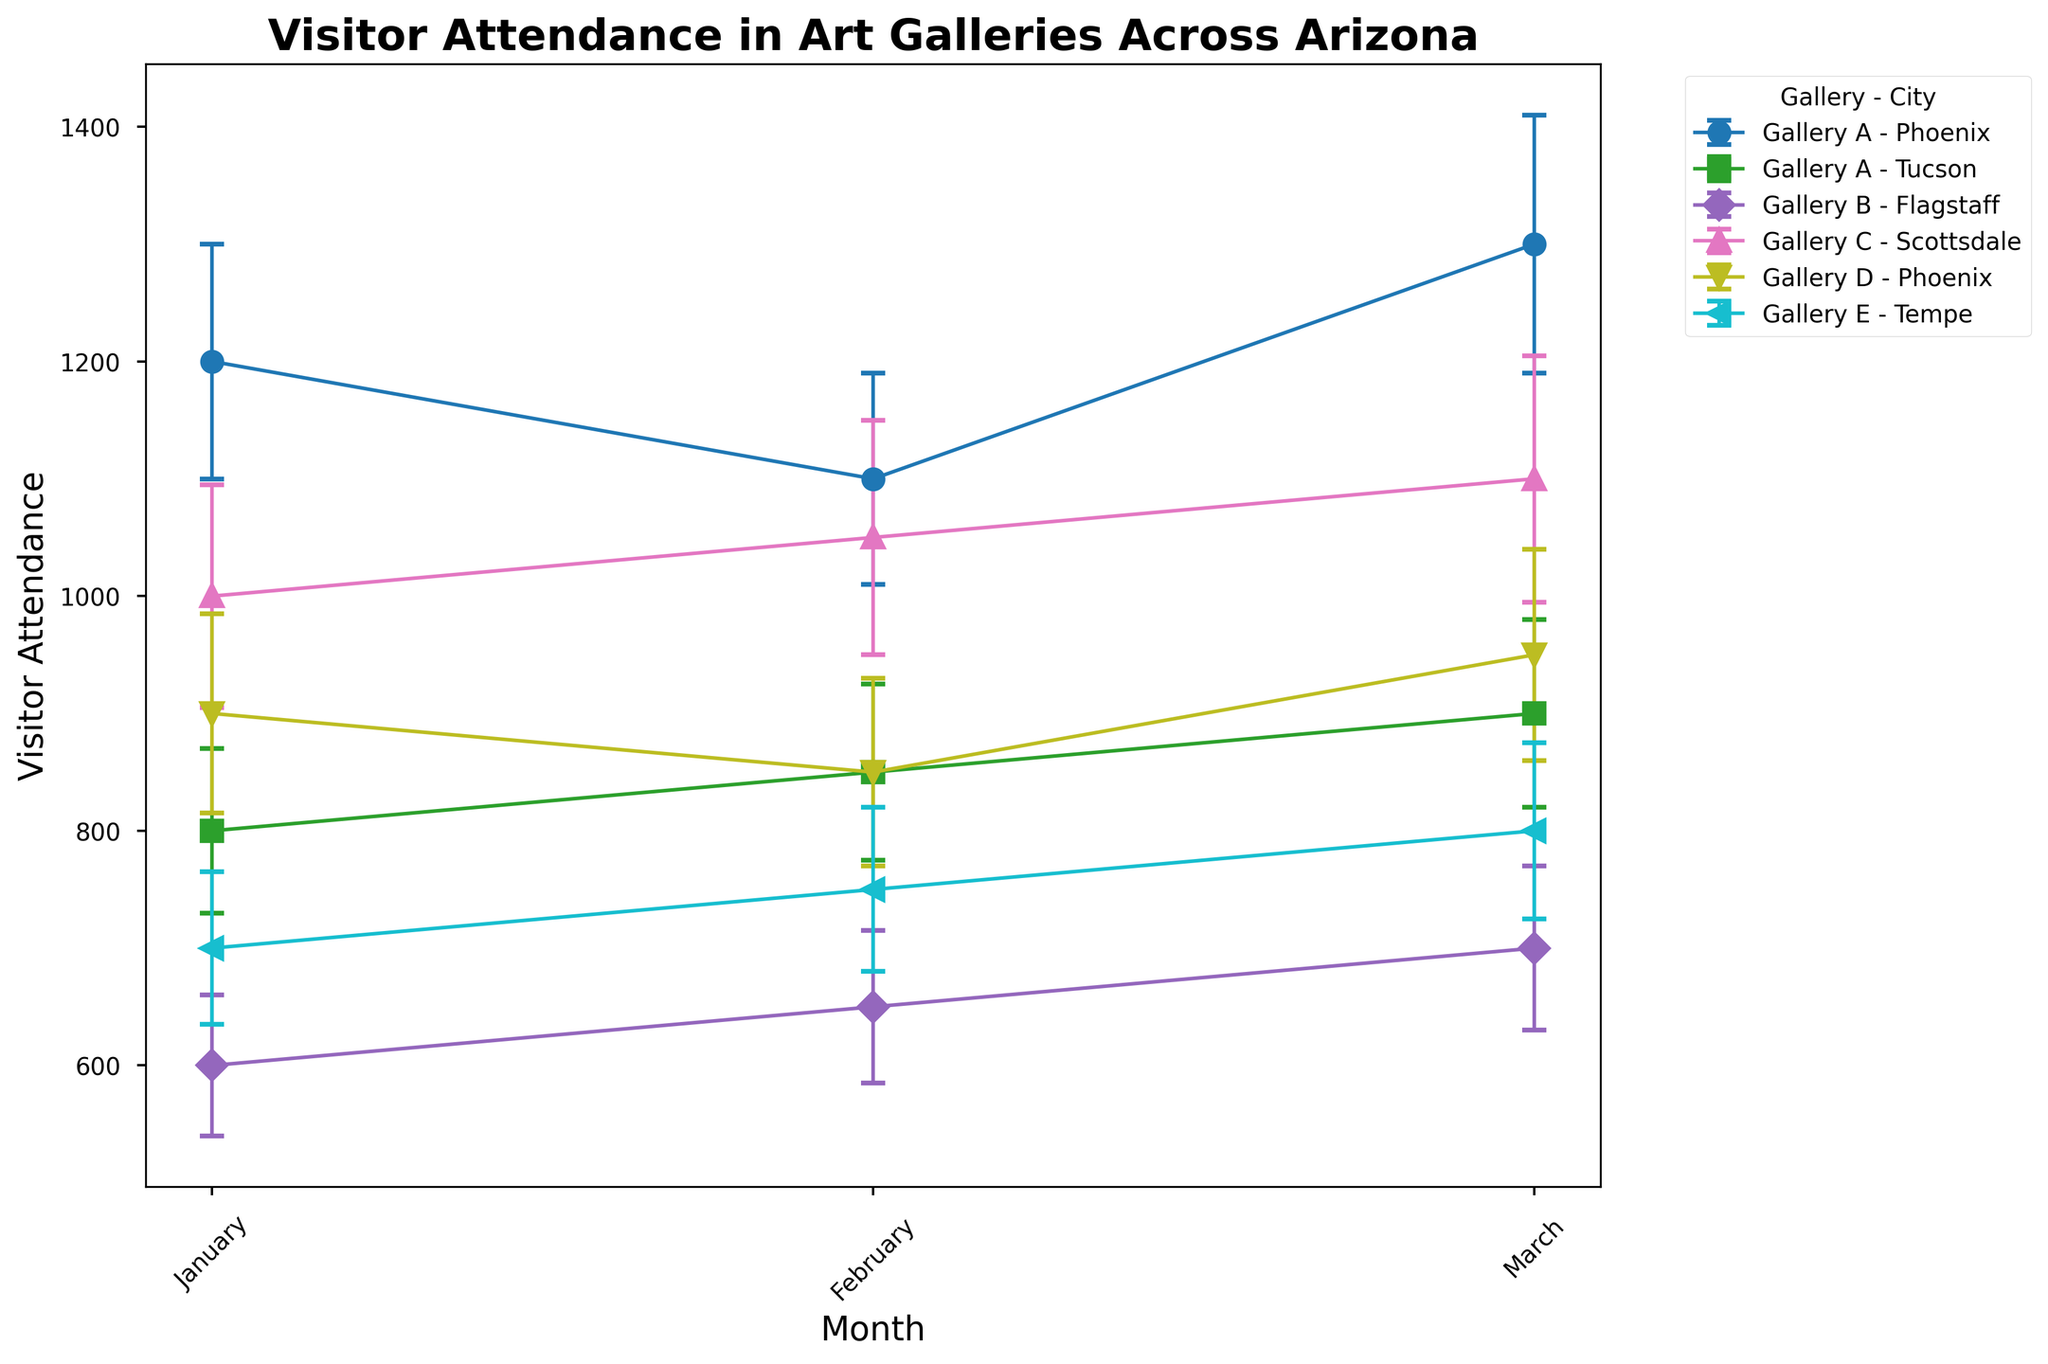what's the overall trend in visitor attendance for Gallery A in Phoenix from January to March? To determine the overall trend in visitor attendance for Gallery A in Phoenix, plot the attendance values for January, February, and March. The values are 1200, 1100, and 1300, respectively, which indicates an overall increase.
Answer: Increasing which gallery had the highest visitor attendance in January across all cities? Look at the visitor attendance values for January for each gallery. The values are 1200 (Gallery A Phoenix), 800 (Gallery A Tucson), 600 (Gallery B Flagstaff), 1000 (Gallery C Scottsdale), 900 (Gallery D Phoenix), 700 (Gallery E Tempe), and 750 (Gallery F Mesa). Gallery A in Phoenix had the highest attendance.
Answer: Gallery A in Phoenix compare the sales revenue trends for Gallery B in Flagstaff and Gallery C in Scottsdale from January to March. Which gallery shows a larger overall increase? Check the sales revenue values and plot them for Gallery B in Flagstaff (7500, 7800, 8000) and Gallery C in Scottsdale (12500, 13000, 13500). Calculate the difference for each gallery: Gallery B's increase is 8000-7500 = 500, Gallery C's increase is 13500-12500 = 1000. Gallery C shows a larger overall increase.
Answer: Gallery C which city shows the most stable visitor attendance for Gallery A from January to March, considering the error bars? Examine the error bars for Gallery A's visitor attendance in both Phoenix and Tucson. The variation in error bars' height in Phoenix is 10 (1200±100 to 1100±90 to 1300±110) and in Tucson is 10 (800±70 to 850±75 to 900±80). Phoenix has a slightly higher stability in error bars.
Answer: Phoenix what is the average visitor attendance for Gallery F in Mesa across January to March? Sum the visitor attendance for Gallery F in Mesa across January (750), February (800), and March (850) and then divide by the number of months: (750 + 800 + 850) / 3 = 2400 / 3 = 800.
Answer: 800 which gallery-city combination has the smallest error bars for visitor attendance, and in which month? Identify the smallest error bar value for visitor attendance. The smallest is 60 for Gallery B in Flagstaff in January.
Answer: Gallery B in Flagstaff, January compare the visitor attendance of Gallery D in Phoenix to that of Gallery E in Tempe for February. Which gallery had higher attendance? Compare the February values: Gallery D in Phoenix (850), Gallery E in Tempe (750). Gallery D in Phoenix had higher attendance.
Answer: Gallery D in Phoenix what is the total sales revenue for Gallery C in Scottsdale from January to March? Sum the sales revenue for Gallery C in Scottsdale across January (12500), February (13000), and March (13500). Total is 12500 + 13000 + 13500 = 39000.
Answer: 39000 